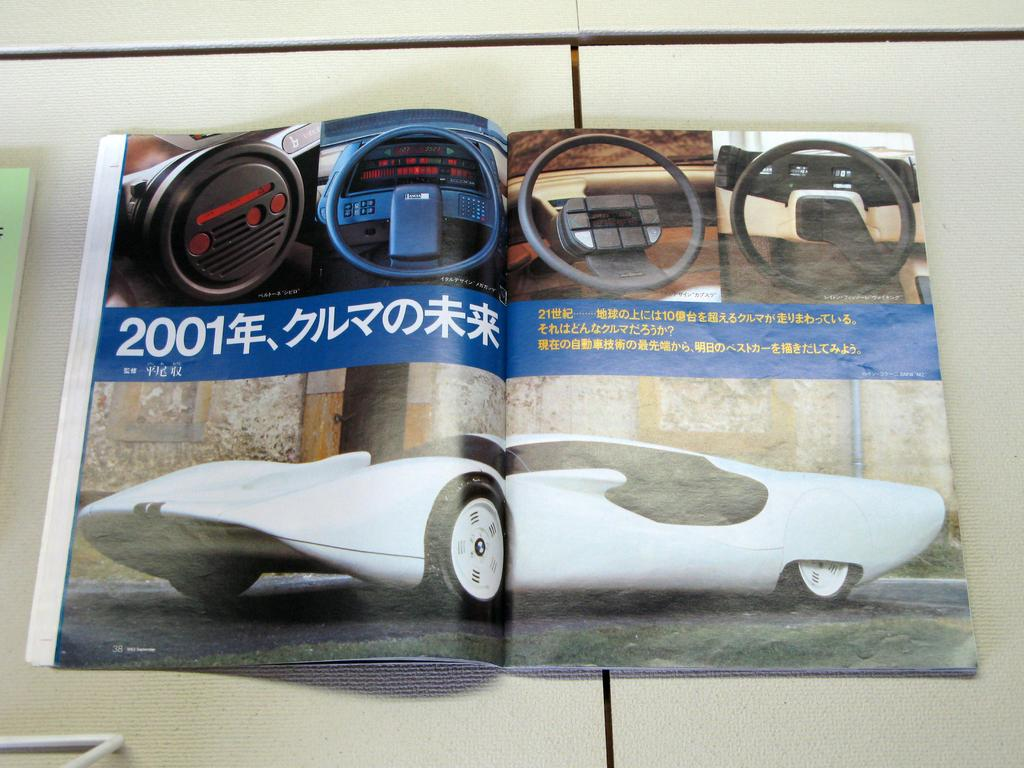What object can be seen in the image? There is a book in the image. Where is the book located? The book is placed on a table. What type of furniture is present at the meeting in the image? There is no meeting or furniture present in the image; it only features a book placed on a table. 